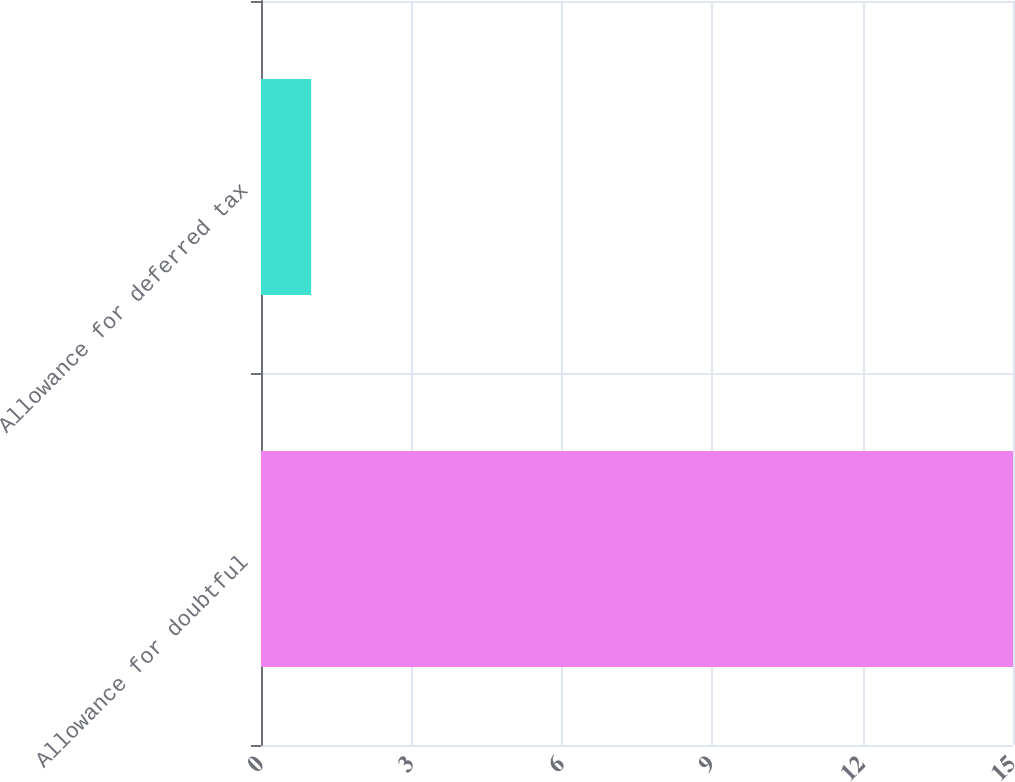Convert chart to OTSL. <chart><loc_0><loc_0><loc_500><loc_500><bar_chart><fcel>Allowance for doubtful<fcel>Allowance for deferred tax<nl><fcel>15<fcel>1<nl></chart> 